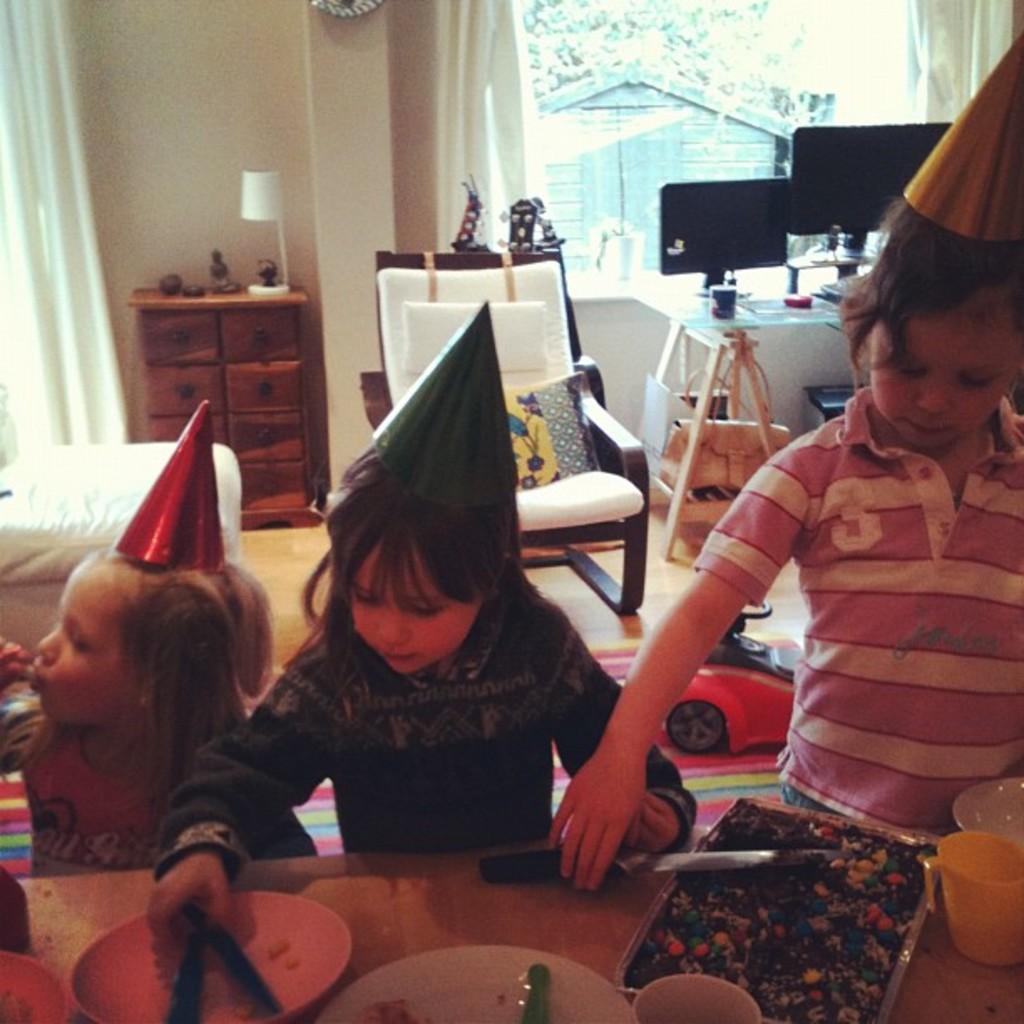Could you give a brief overview of what you see in this image? In this picture we can see three kids standing in front of a table and on the table we can see a plum cake, plates, mug and a bowl. These kids wore caps. on the background we can see window, curtains, desk, chair with cushions, cradle and on the table we can see monitors screens. Through window glass we can see trees. 